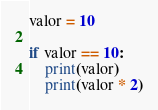Convert code to text. <code><loc_0><loc_0><loc_500><loc_500><_Python_>valor = 10

if valor == 10:
    print(valor)
    print(valor * 2)

</code> 